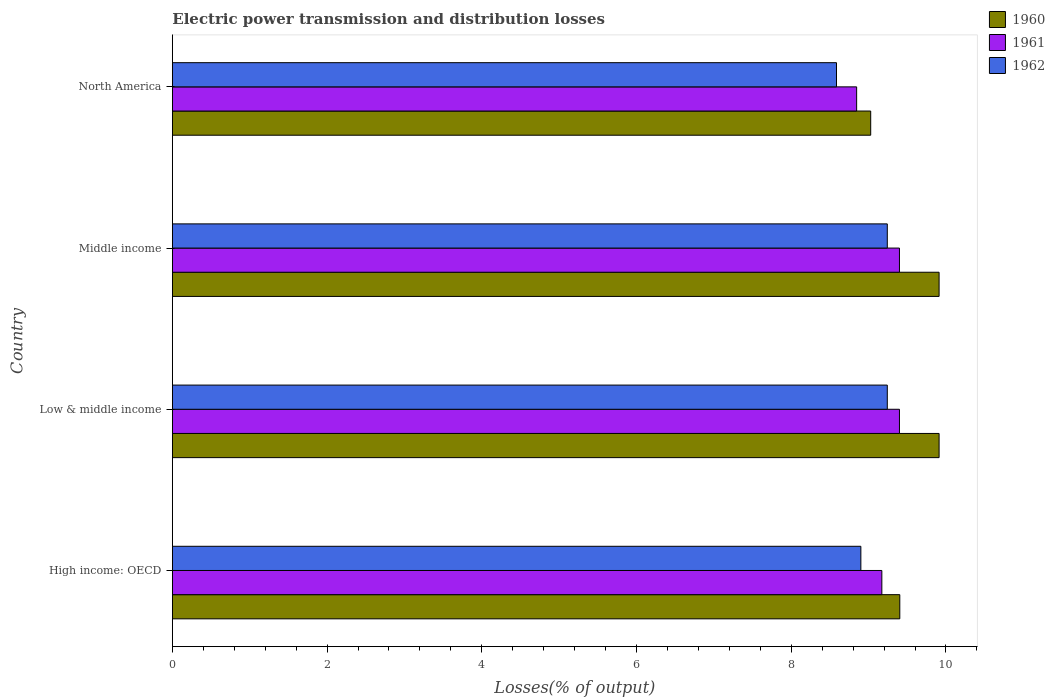How many different coloured bars are there?
Your answer should be compact. 3. How many groups of bars are there?
Provide a succinct answer. 4. Are the number of bars per tick equal to the number of legend labels?
Keep it short and to the point. Yes. In how many cases, is the number of bars for a given country not equal to the number of legend labels?
Keep it short and to the point. 0. What is the electric power transmission and distribution losses in 1960 in High income: OECD?
Make the answer very short. 9.4. Across all countries, what is the maximum electric power transmission and distribution losses in 1962?
Make the answer very short. 9.24. Across all countries, what is the minimum electric power transmission and distribution losses in 1961?
Your answer should be compact. 8.85. What is the total electric power transmission and distribution losses in 1961 in the graph?
Your answer should be compact. 36.81. What is the difference between the electric power transmission and distribution losses in 1962 in High income: OECD and that in Low & middle income?
Give a very brief answer. -0.34. What is the difference between the electric power transmission and distribution losses in 1962 in Middle income and the electric power transmission and distribution losses in 1961 in High income: OECD?
Your answer should be very brief. 0.07. What is the average electric power transmission and distribution losses in 1962 per country?
Your response must be concise. 8.99. What is the difference between the electric power transmission and distribution losses in 1962 and electric power transmission and distribution losses in 1961 in High income: OECD?
Offer a very short reply. -0.27. In how many countries, is the electric power transmission and distribution losses in 1961 greater than 6.4 %?
Ensure brevity in your answer.  4. What is the ratio of the electric power transmission and distribution losses in 1960 in Middle income to that in North America?
Keep it short and to the point. 1.1. Is the electric power transmission and distribution losses in 1961 in High income: OECD less than that in North America?
Offer a terse response. No. Is the difference between the electric power transmission and distribution losses in 1962 in High income: OECD and Low & middle income greater than the difference between the electric power transmission and distribution losses in 1961 in High income: OECD and Low & middle income?
Your answer should be very brief. No. What is the difference between the highest and the lowest electric power transmission and distribution losses in 1961?
Provide a succinct answer. 0.55. In how many countries, is the electric power transmission and distribution losses in 1961 greater than the average electric power transmission and distribution losses in 1961 taken over all countries?
Make the answer very short. 2. What does the 1st bar from the top in Low & middle income represents?
Ensure brevity in your answer.  1962. What does the 2nd bar from the bottom in North America represents?
Give a very brief answer. 1961. Is it the case that in every country, the sum of the electric power transmission and distribution losses in 1962 and electric power transmission and distribution losses in 1961 is greater than the electric power transmission and distribution losses in 1960?
Provide a short and direct response. Yes. How many countries are there in the graph?
Offer a very short reply. 4. What is the difference between two consecutive major ticks on the X-axis?
Offer a very short reply. 2. Does the graph contain any zero values?
Provide a succinct answer. No. What is the title of the graph?
Offer a terse response. Electric power transmission and distribution losses. What is the label or title of the X-axis?
Make the answer very short. Losses(% of output). What is the Losses(% of output) of 1960 in High income: OECD?
Make the answer very short. 9.4. What is the Losses(% of output) in 1961 in High income: OECD?
Your answer should be compact. 9.17. What is the Losses(% of output) of 1962 in High income: OECD?
Give a very brief answer. 8.9. What is the Losses(% of output) in 1960 in Low & middle income?
Give a very brief answer. 9.91. What is the Losses(% of output) in 1961 in Low & middle income?
Provide a succinct answer. 9.4. What is the Losses(% of output) of 1962 in Low & middle income?
Provide a succinct answer. 9.24. What is the Losses(% of output) of 1960 in Middle income?
Ensure brevity in your answer.  9.91. What is the Losses(% of output) of 1961 in Middle income?
Provide a succinct answer. 9.4. What is the Losses(% of output) of 1962 in Middle income?
Make the answer very short. 9.24. What is the Losses(% of output) of 1960 in North America?
Keep it short and to the point. 9.03. What is the Losses(% of output) in 1961 in North America?
Offer a very short reply. 8.85. What is the Losses(% of output) of 1962 in North America?
Offer a terse response. 8.59. Across all countries, what is the maximum Losses(% of output) in 1960?
Make the answer very short. 9.91. Across all countries, what is the maximum Losses(% of output) in 1961?
Offer a very short reply. 9.4. Across all countries, what is the maximum Losses(% of output) in 1962?
Keep it short and to the point. 9.24. Across all countries, what is the minimum Losses(% of output) in 1960?
Ensure brevity in your answer.  9.03. Across all countries, what is the minimum Losses(% of output) in 1961?
Your response must be concise. 8.85. Across all countries, what is the minimum Losses(% of output) in 1962?
Make the answer very short. 8.59. What is the total Losses(% of output) of 1960 in the graph?
Keep it short and to the point. 38.25. What is the total Losses(% of output) of 1961 in the graph?
Provide a short and direct response. 36.81. What is the total Losses(% of output) in 1962 in the graph?
Your answer should be very brief. 35.97. What is the difference between the Losses(% of output) of 1960 in High income: OECD and that in Low & middle income?
Your answer should be compact. -0.51. What is the difference between the Losses(% of output) in 1961 in High income: OECD and that in Low & middle income?
Your answer should be very brief. -0.23. What is the difference between the Losses(% of output) in 1962 in High income: OECD and that in Low & middle income?
Your answer should be compact. -0.34. What is the difference between the Losses(% of output) in 1960 in High income: OECD and that in Middle income?
Provide a short and direct response. -0.51. What is the difference between the Losses(% of output) in 1961 in High income: OECD and that in Middle income?
Give a very brief answer. -0.23. What is the difference between the Losses(% of output) in 1962 in High income: OECD and that in Middle income?
Offer a terse response. -0.34. What is the difference between the Losses(% of output) of 1960 in High income: OECD and that in North America?
Ensure brevity in your answer.  0.38. What is the difference between the Losses(% of output) of 1961 in High income: OECD and that in North America?
Keep it short and to the point. 0.33. What is the difference between the Losses(% of output) of 1962 in High income: OECD and that in North America?
Your answer should be very brief. 0.31. What is the difference between the Losses(% of output) of 1961 in Low & middle income and that in Middle income?
Provide a short and direct response. 0. What is the difference between the Losses(% of output) of 1960 in Low & middle income and that in North America?
Your response must be concise. 0.88. What is the difference between the Losses(% of output) of 1961 in Low & middle income and that in North America?
Ensure brevity in your answer.  0.55. What is the difference between the Losses(% of output) in 1962 in Low & middle income and that in North America?
Give a very brief answer. 0.66. What is the difference between the Losses(% of output) in 1960 in Middle income and that in North America?
Provide a short and direct response. 0.88. What is the difference between the Losses(% of output) in 1961 in Middle income and that in North America?
Offer a very short reply. 0.55. What is the difference between the Losses(% of output) of 1962 in Middle income and that in North America?
Your answer should be very brief. 0.66. What is the difference between the Losses(% of output) of 1960 in High income: OECD and the Losses(% of output) of 1961 in Low & middle income?
Make the answer very short. 0. What is the difference between the Losses(% of output) of 1960 in High income: OECD and the Losses(% of output) of 1962 in Low & middle income?
Provide a short and direct response. 0.16. What is the difference between the Losses(% of output) in 1961 in High income: OECD and the Losses(% of output) in 1962 in Low & middle income?
Your response must be concise. -0.07. What is the difference between the Losses(% of output) of 1960 in High income: OECD and the Losses(% of output) of 1961 in Middle income?
Provide a short and direct response. 0. What is the difference between the Losses(% of output) in 1960 in High income: OECD and the Losses(% of output) in 1962 in Middle income?
Your answer should be compact. 0.16. What is the difference between the Losses(% of output) in 1961 in High income: OECD and the Losses(% of output) in 1962 in Middle income?
Provide a succinct answer. -0.07. What is the difference between the Losses(% of output) of 1960 in High income: OECD and the Losses(% of output) of 1961 in North America?
Provide a succinct answer. 0.56. What is the difference between the Losses(% of output) of 1960 in High income: OECD and the Losses(% of output) of 1962 in North America?
Offer a terse response. 0.82. What is the difference between the Losses(% of output) of 1961 in High income: OECD and the Losses(% of output) of 1962 in North America?
Make the answer very short. 0.59. What is the difference between the Losses(% of output) in 1960 in Low & middle income and the Losses(% of output) in 1961 in Middle income?
Give a very brief answer. 0.51. What is the difference between the Losses(% of output) of 1960 in Low & middle income and the Losses(% of output) of 1962 in Middle income?
Offer a very short reply. 0.67. What is the difference between the Losses(% of output) in 1961 in Low & middle income and the Losses(% of output) in 1962 in Middle income?
Ensure brevity in your answer.  0.16. What is the difference between the Losses(% of output) in 1960 in Low & middle income and the Losses(% of output) in 1961 in North America?
Your answer should be compact. 1.07. What is the difference between the Losses(% of output) of 1960 in Low & middle income and the Losses(% of output) of 1962 in North America?
Give a very brief answer. 1.33. What is the difference between the Losses(% of output) of 1961 in Low & middle income and the Losses(% of output) of 1962 in North America?
Offer a terse response. 0.81. What is the difference between the Losses(% of output) of 1960 in Middle income and the Losses(% of output) of 1961 in North America?
Provide a short and direct response. 1.07. What is the difference between the Losses(% of output) of 1960 in Middle income and the Losses(% of output) of 1962 in North America?
Keep it short and to the point. 1.33. What is the difference between the Losses(% of output) of 1961 in Middle income and the Losses(% of output) of 1962 in North America?
Provide a succinct answer. 0.81. What is the average Losses(% of output) in 1960 per country?
Your response must be concise. 9.56. What is the average Losses(% of output) in 1961 per country?
Your answer should be compact. 9.2. What is the average Losses(% of output) of 1962 per country?
Provide a succinct answer. 8.99. What is the difference between the Losses(% of output) in 1960 and Losses(% of output) in 1961 in High income: OECD?
Your answer should be compact. 0.23. What is the difference between the Losses(% of output) of 1960 and Losses(% of output) of 1962 in High income: OECD?
Offer a terse response. 0.5. What is the difference between the Losses(% of output) in 1961 and Losses(% of output) in 1962 in High income: OECD?
Ensure brevity in your answer.  0.27. What is the difference between the Losses(% of output) of 1960 and Losses(% of output) of 1961 in Low & middle income?
Provide a short and direct response. 0.51. What is the difference between the Losses(% of output) of 1960 and Losses(% of output) of 1962 in Low & middle income?
Offer a very short reply. 0.67. What is the difference between the Losses(% of output) in 1961 and Losses(% of output) in 1962 in Low & middle income?
Your answer should be compact. 0.16. What is the difference between the Losses(% of output) of 1960 and Losses(% of output) of 1961 in Middle income?
Your response must be concise. 0.51. What is the difference between the Losses(% of output) of 1960 and Losses(% of output) of 1962 in Middle income?
Give a very brief answer. 0.67. What is the difference between the Losses(% of output) in 1961 and Losses(% of output) in 1962 in Middle income?
Give a very brief answer. 0.16. What is the difference between the Losses(% of output) of 1960 and Losses(% of output) of 1961 in North America?
Provide a succinct answer. 0.18. What is the difference between the Losses(% of output) of 1960 and Losses(% of output) of 1962 in North America?
Offer a terse response. 0.44. What is the difference between the Losses(% of output) of 1961 and Losses(% of output) of 1962 in North America?
Your response must be concise. 0.26. What is the ratio of the Losses(% of output) in 1960 in High income: OECD to that in Low & middle income?
Provide a short and direct response. 0.95. What is the ratio of the Losses(% of output) in 1961 in High income: OECD to that in Low & middle income?
Your answer should be very brief. 0.98. What is the ratio of the Losses(% of output) in 1960 in High income: OECD to that in Middle income?
Provide a short and direct response. 0.95. What is the ratio of the Losses(% of output) in 1961 in High income: OECD to that in Middle income?
Keep it short and to the point. 0.98. What is the ratio of the Losses(% of output) of 1962 in High income: OECD to that in Middle income?
Give a very brief answer. 0.96. What is the ratio of the Losses(% of output) in 1960 in High income: OECD to that in North America?
Provide a short and direct response. 1.04. What is the ratio of the Losses(% of output) of 1961 in High income: OECD to that in North America?
Keep it short and to the point. 1.04. What is the ratio of the Losses(% of output) of 1962 in High income: OECD to that in North America?
Your answer should be very brief. 1.04. What is the ratio of the Losses(% of output) in 1961 in Low & middle income to that in Middle income?
Offer a very short reply. 1. What is the ratio of the Losses(% of output) of 1960 in Low & middle income to that in North America?
Your answer should be compact. 1.1. What is the ratio of the Losses(% of output) of 1961 in Low & middle income to that in North America?
Your answer should be very brief. 1.06. What is the ratio of the Losses(% of output) in 1962 in Low & middle income to that in North America?
Your response must be concise. 1.08. What is the ratio of the Losses(% of output) in 1960 in Middle income to that in North America?
Provide a short and direct response. 1.1. What is the ratio of the Losses(% of output) of 1961 in Middle income to that in North America?
Offer a terse response. 1.06. What is the ratio of the Losses(% of output) in 1962 in Middle income to that in North America?
Ensure brevity in your answer.  1.08. What is the difference between the highest and the lowest Losses(% of output) of 1960?
Keep it short and to the point. 0.88. What is the difference between the highest and the lowest Losses(% of output) in 1961?
Ensure brevity in your answer.  0.55. What is the difference between the highest and the lowest Losses(% of output) in 1962?
Provide a succinct answer. 0.66. 